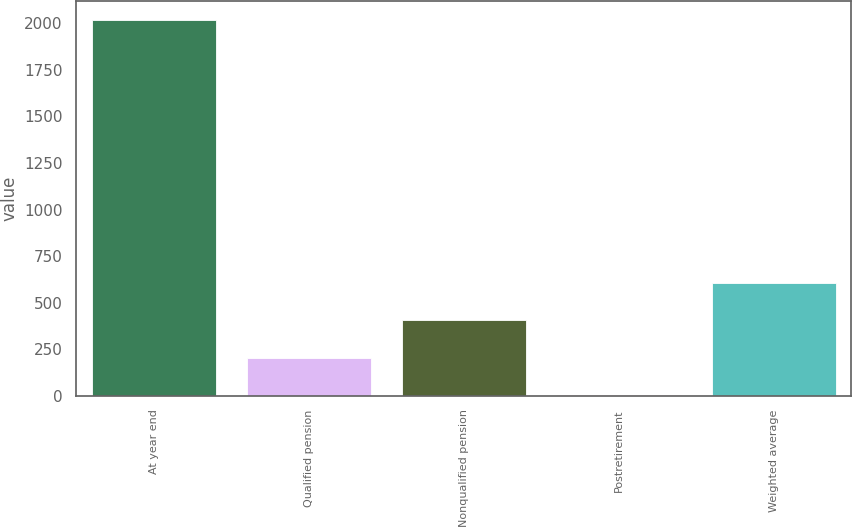Convert chart. <chart><loc_0><loc_0><loc_500><loc_500><bar_chart><fcel>At year end<fcel>Qualified pension<fcel>Nonqualified pension<fcel>Postretirement<fcel>Weighted average<nl><fcel>2017<fcel>204.85<fcel>406.2<fcel>3.5<fcel>607.55<nl></chart> 